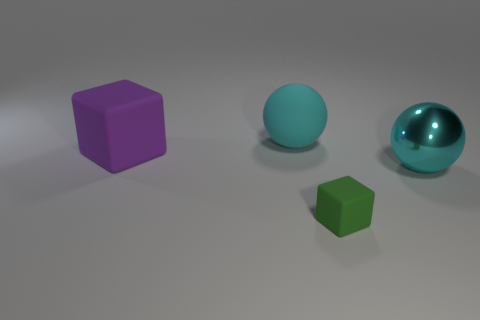Are the shadows consistent with one another? What does that tell us about the light source? Yes, the shadows cast by the objects are consistent in direction, indicating that there is a single light source in the scene. This coherence suggests that the light source is off-camera to the left, possibly at a mid-level angle given the length and angle of the shadows. 